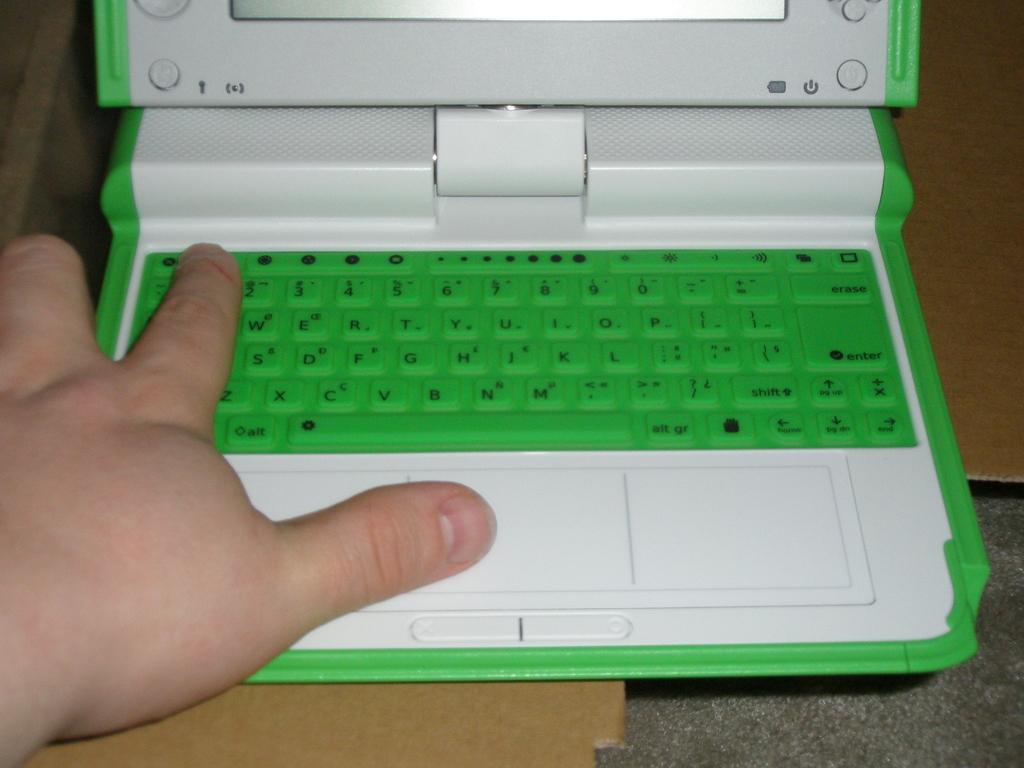What text is shown on the bottom row of keys?
Provide a succinct answer. Zxcvbnm. What key is the person about to click on?
Offer a terse response. 1. 